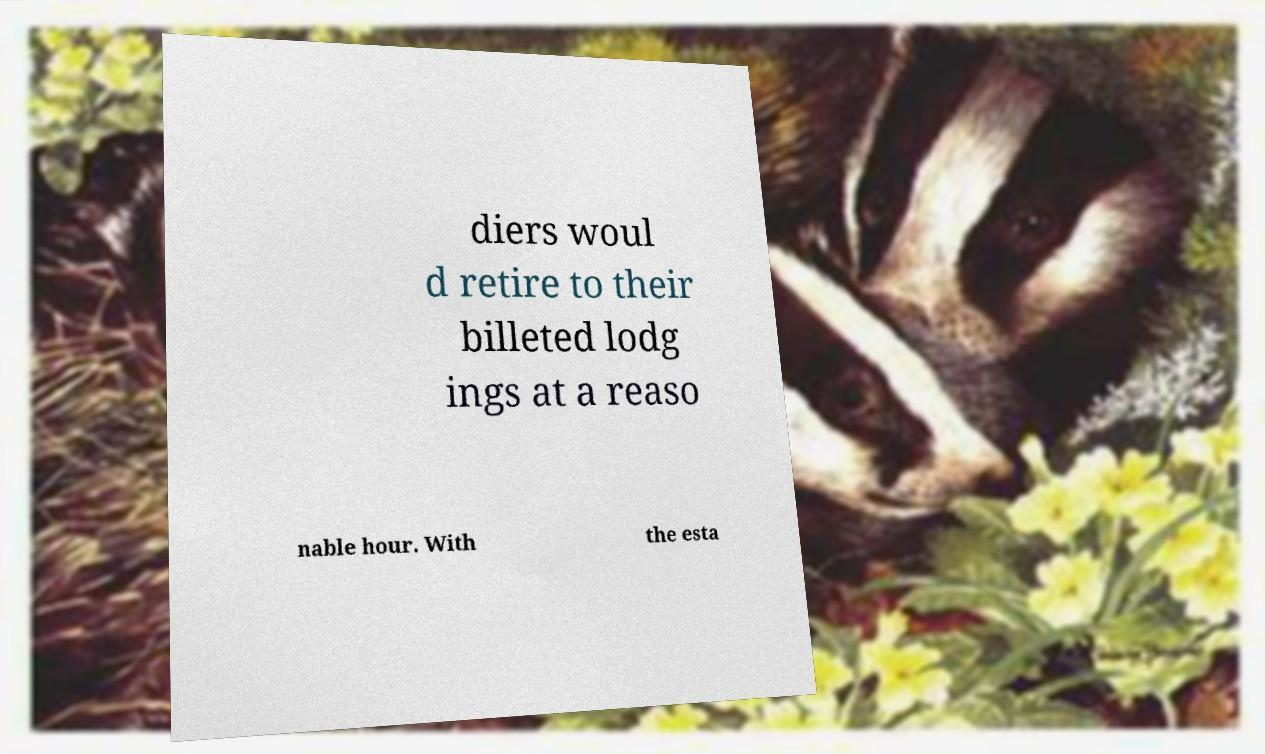Can you accurately transcribe the text from the provided image for me? diers woul d retire to their billeted lodg ings at a reaso nable hour. With the esta 